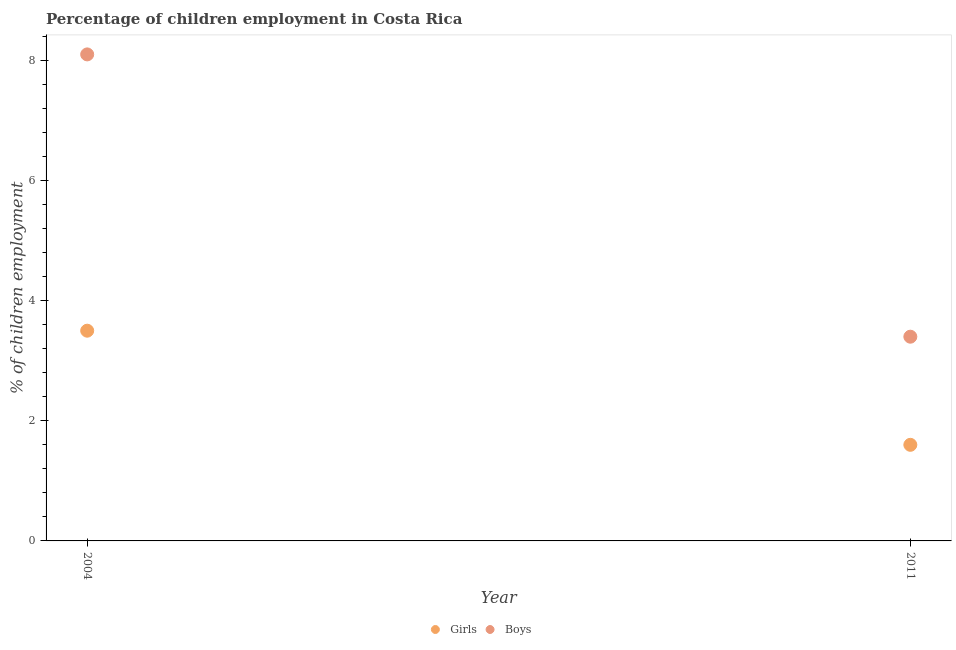Is the number of dotlines equal to the number of legend labels?
Offer a very short reply. Yes. Across all years, what is the maximum percentage of employed boys?
Offer a very short reply. 8.1. Across all years, what is the minimum percentage of employed boys?
Offer a very short reply. 3.4. In which year was the percentage of employed boys maximum?
Give a very brief answer. 2004. What is the total percentage of employed girls in the graph?
Your answer should be compact. 5.1. What is the difference between the percentage of employed boys in 2004 and that in 2011?
Your answer should be compact. 4.7. What is the average percentage of employed girls per year?
Provide a short and direct response. 2.55. In the year 2011, what is the difference between the percentage of employed boys and percentage of employed girls?
Ensure brevity in your answer.  1.8. In how many years, is the percentage of employed girls greater than 4 %?
Your answer should be compact. 0. What is the ratio of the percentage of employed boys in 2004 to that in 2011?
Your answer should be compact. 2.38. Is the percentage of employed girls strictly greater than the percentage of employed boys over the years?
Provide a succinct answer. No. Is the percentage of employed girls strictly less than the percentage of employed boys over the years?
Provide a short and direct response. Yes. Does the graph contain any zero values?
Your response must be concise. No. Does the graph contain grids?
Provide a short and direct response. No. Where does the legend appear in the graph?
Give a very brief answer. Bottom center. How are the legend labels stacked?
Offer a very short reply. Horizontal. What is the title of the graph?
Offer a very short reply. Percentage of children employment in Costa Rica. Does "Methane emissions" appear as one of the legend labels in the graph?
Provide a succinct answer. No. What is the label or title of the Y-axis?
Offer a terse response. % of children employment. What is the % of children employment of Boys in 2011?
Make the answer very short. 3.4. What is the total % of children employment of Girls in the graph?
Provide a succinct answer. 5.1. What is the difference between the % of children employment in Girls in 2004 and that in 2011?
Your answer should be compact. 1.9. What is the difference between the % of children employment in Girls in 2004 and the % of children employment in Boys in 2011?
Ensure brevity in your answer.  0.1. What is the average % of children employment in Girls per year?
Give a very brief answer. 2.55. What is the average % of children employment of Boys per year?
Your response must be concise. 5.75. In the year 2004, what is the difference between the % of children employment in Girls and % of children employment in Boys?
Give a very brief answer. -4.6. What is the ratio of the % of children employment of Girls in 2004 to that in 2011?
Give a very brief answer. 2.19. What is the ratio of the % of children employment in Boys in 2004 to that in 2011?
Make the answer very short. 2.38. What is the difference between the highest and the second highest % of children employment in Girls?
Offer a very short reply. 1.9. What is the difference between the highest and the second highest % of children employment in Boys?
Offer a very short reply. 4.7. What is the difference between the highest and the lowest % of children employment in Girls?
Your answer should be compact. 1.9. 